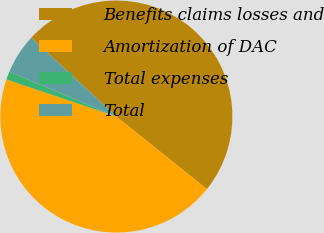Convert chart. <chart><loc_0><loc_0><loc_500><loc_500><pie_chart><fcel>Benefits claims losses and<fcel>Amortization of DAC<fcel>Total expenses<fcel>Total<nl><fcel>48.86%<fcel>44.42%<fcel>1.14%<fcel>5.58%<nl></chart> 